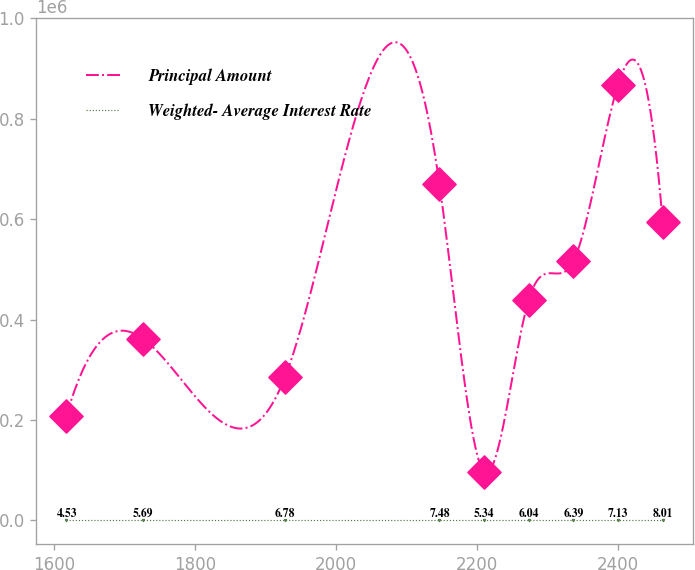Convert chart to OTSL. <chart><loc_0><loc_0><loc_500><loc_500><line_chart><ecel><fcel>Principal Amount<fcel>Weighted- Average Interest Rate<nl><fcel>1617.16<fcel>207671<fcel>4.53<nl><fcel>1725.61<fcel>362014<fcel>5.69<nl><fcel>1927.24<fcel>284842<fcel>6.78<nl><fcel>2146.36<fcel>670699<fcel>7.48<nl><fcel>2209.72<fcel>96310.4<fcel>5.34<nl><fcel>2273.08<fcel>439185<fcel>6.04<nl><fcel>2336.44<fcel>516357<fcel>6.39<nl><fcel>2399.8<fcel>868024<fcel>7.13<nl><fcel>2463.16<fcel>593528<fcel>8.01<nl></chart> 